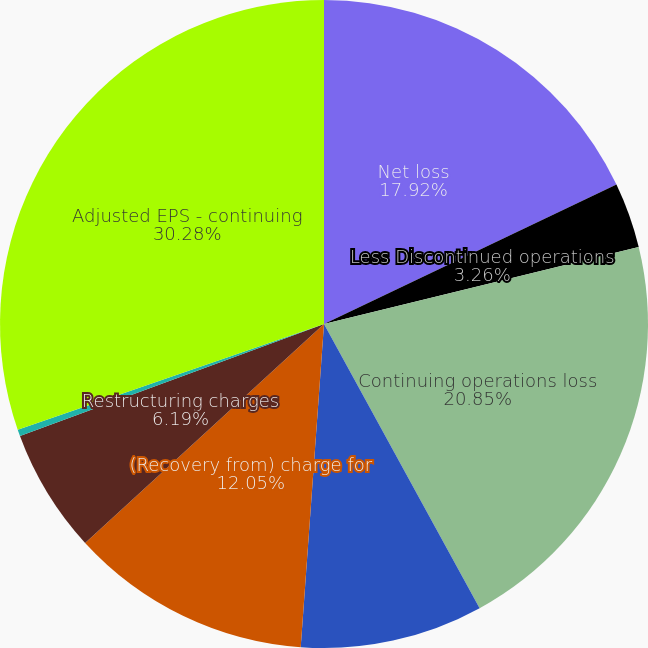Convert chart. <chart><loc_0><loc_0><loc_500><loc_500><pie_chart><fcel>Net loss<fcel>Less Discontinued operations<fcel>Continuing operations loss<fcel>Gain on sale of real estate<fcel>(Recovery from) charge for<fcel>Restructuring charges<fcel>Exchange offer costs<fcel>Adjusted EPS - continuing<nl><fcel>17.92%<fcel>3.26%<fcel>20.85%<fcel>9.12%<fcel>12.05%<fcel>6.19%<fcel>0.33%<fcel>30.29%<nl></chart> 